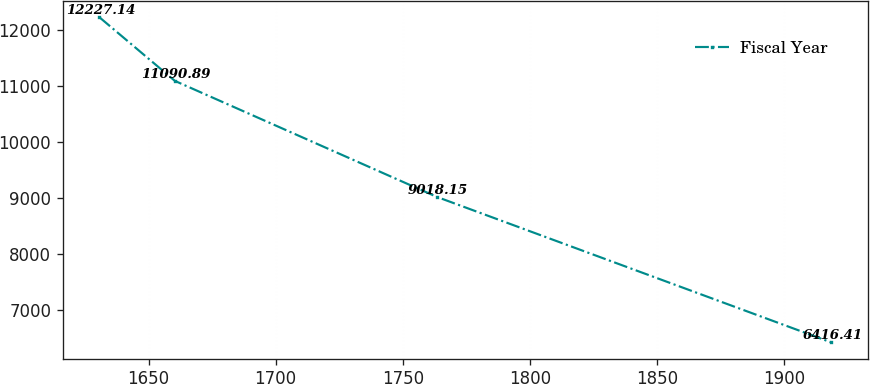<chart> <loc_0><loc_0><loc_500><loc_500><line_chart><ecel><fcel>Fiscal Year<nl><fcel>1630.68<fcel>12227.1<nl><fcel>1660.36<fcel>11090.9<nl><fcel>1763.42<fcel>9018.15<nl><fcel>1918.69<fcel>6416.41<nl></chart> 